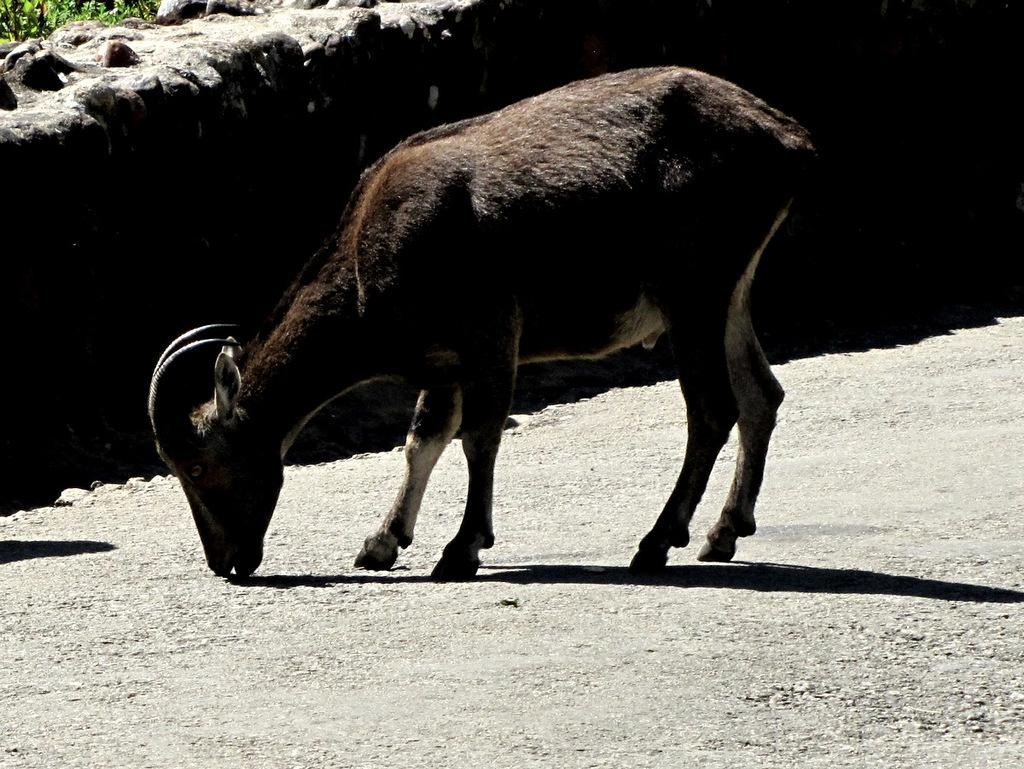What type of animal is present in the image? There is an animal in the image, but its specific type cannot be determined from the provided facts. Can you describe the position of the animal in the image? The animal is on the ground in the image. What is visible in the background of the image? There is a wall in the background of the image. What type of powder is being used by the animal in the image? There is no indication in the image that any powder is being used by the animal. How does the animal hear in the image? The image does not provide any information about the animal's hearing abilities. 